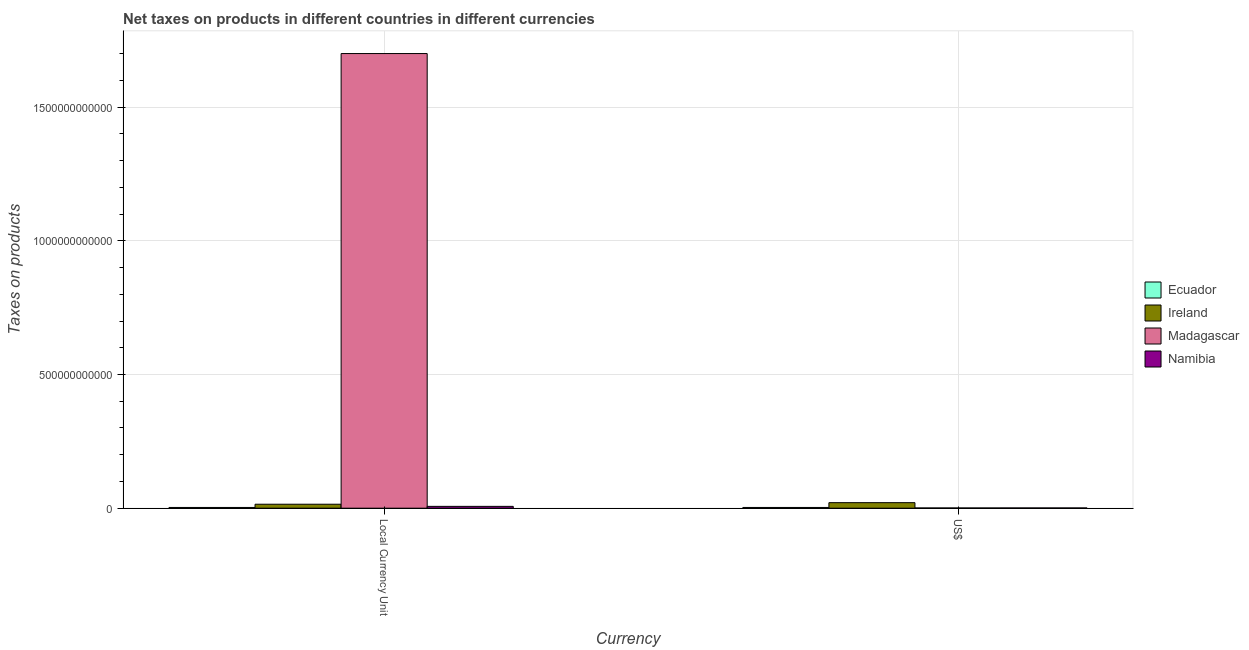How many groups of bars are there?
Your answer should be compact. 2. Are the number of bars per tick equal to the number of legend labels?
Your response must be concise. Yes. Are the number of bars on each tick of the X-axis equal?
Ensure brevity in your answer.  Yes. How many bars are there on the 2nd tick from the left?
Provide a short and direct response. 4. How many bars are there on the 1st tick from the right?
Your answer should be compact. 4. What is the label of the 2nd group of bars from the left?
Keep it short and to the point. US$. What is the net taxes in us$ in Madagascar?
Provide a short and direct response. 8.40e+08. Across all countries, what is the maximum net taxes in constant 2005 us$?
Provide a succinct answer. 1.70e+12. Across all countries, what is the minimum net taxes in constant 2005 us$?
Make the answer very short. 2.74e+09. In which country was the net taxes in constant 2005 us$ maximum?
Your response must be concise. Madagascar. In which country was the net taxes in us$ minimum?
Provide a succinct answer. Madagascar. What is the total net taxes in constant 2005 us$ in the graph?
Keep it short and to the point. 1.73e+12. What is the difference between the net taxes in constant 2005 us$ in Ecuador and that in Madagascar?
Give a very brief answer. -1.70e+12. What is the difference between the net taxes in us$ in Madagascar and the net taxes in constant 2005 us$ in Ecuador?
Offer a terse response. -1.90e+09. What is the average net taxes in constant 2005 us$ per country?
Your answer should be compact. 4.31e+11. What is the difference between the net taxes in constant 2005 us$ and net taxes in us$ in Madagascar?
Your response must be concise. 1.70e+12. In how many countries, is the net taxes in constant 2005 us$ greater than 1500000000000 units?
Offer a terse response. 1. What is the ratio of the net taxes in constant 2005 us$ in Namibia to that in Madagascar?
Offer a terse response. 0. Is the net taxes in constant 2005 us$ in Ireland less than that in Namibia?
Provide a succinct answer. No. What does the 4th bar from the left in Local Currency Unit represents?
Provide a short and direct response. Namibia. What does the 1st bar from the right in US$ represents?
Make the answer very short. Namibia. How many bars are there?
Your answer should be compact. 8. Are all the bars in the graph horizontal?
Provide a succinct answer. No. What is the difference between two consecutive major ticks on the Y-axis?
Offer a terse response. 5.00e+11. Does the graph contain any zero values?
Give a very brief answer. No. What is the title of the graph?
Your answer should be very brief. Net taxes on products in different countries in different currencies. Does "Morocco" appear as one of the legend labels in the graph?
Give a very brief answer. No. What is the label or title of the X-axis?
Ensure brevity in your answer.  Currency. What is the label or title of the Y-axis?
Offer a very short reply. Taxes on products. What is the Taxes on products in Ecuador in Local Currency Unit?
Offer a terse response. 2.74e+09. What is the Taxes on products of Ireland in Local Currency Unit?
Your answer should be compact. 1.49e+1. What is the Taxes on products of Madagascar in Local Currency Unit?
Provide a short and direct response. 1.70e+12. What is the Taxes on products of Namibia in Local Currency Unit?
Give a very brief answer. 6.81e+09. What is the Taxes on products in Ecuador in US$?
Your response must be concise. 2.74e+09. What is the Taxes on products in Ireland in US$?
Your response must be concise. 2.07e+1. What is the Taxes on products of Madagascar in US$?
Make the answer very short. 8.40e+08. What is the Taxes on products in Namibia in US$?
Your response must be concise. 9.37e+08. Across all Currency, what is the maximum Taxes on products of Ecuador?
Make the answer very short. 2.74e+09. Across all Currency, what is the maximum Taxes on products of Ireland?
Ensure brevity in your answer.  2.07e+1. Across all Currency, what is the maximum Taxes on products of Madagascar?
Provide a short and direct response. 1.70e+12. Across all Currency, what is the maximum Taxes on products of Namibia?
Provide a short and direct response. 6.81e+09. Across all Currency, what is the minimum Taxes on products in Ecuador?
Offer a very short reply. 2.74e+09. Across all Currency, what is the minimum Taxes on products in Ireland?
Your answer should be compact. 1.49e+1. Across all Currency, what is the minimum Taxes on products of Madagascar?
Offer a very short reply. 8.40e+08. Across all Currency, what is the minimum Taxes on products of Namibia?
Keep it short and to the point. 9.37e+08. What is the total Taxes on products of Ecuador in the graph?
Make the answer very short. 5.48e+09. What is the total Taxes on products of Ireland in the graph?
Your answer should be compact. 3.55e+1. What is the total Taxes on products of Madagascar in the graph?
Your response must be concise. 1.70e+12. What is the total Taxes on products of Namibia in the graph?
Give a very brief answer. 7.74e+09. What is the difference between the Taxes on products in Ireland in Local Currency Unit and that in US$?
Give a very brief answer. -5.80e+09. What is the difference between the Taxes on products in Madagascar in Local Currency Unit and that in US$?
Ensure brevity in your answer.  1.70e+12. What is the difference between the Taxes on products in Namibia in Local Currency Unit and that in US$?
Give a very brief answer. 5.87e+09. What is the difference between the Taxes on products of Ecuador in Local Currency Unit and the Taxes on products of Ireland in US$?
Your answer should be very brief. -1.79e+1. What is the difference between the Taxes on products in Ecuador in Local Currency Unit and the Taxes on products in Madagascar in US$?
Make the answer very short. 1.90e+09. What is the difference between the Taxes on products in Ecuador in Local Currency Unit and the Taxes on products in Namibia in US$?
Your answer should be compact. 1.80e+09. What is the difference between the Taxes on products of Ireland in Local Currency Unit and the Taxes on products of Madagascar in US$?
Your response must be concise. 1.40e+1. What is the difference between the Taxes on products in Ireland in Local Currency Unit and the Taxes on products in Namibia in US$?
Provide a succinct answer. 1.39e+1. What is the difference between the Taxes on products of Madagascar in Local Currency Unit and the Taxes on products of Namibia in US$?
Give a very brief answer. 1.70e+12. What is the average Taxes on products of Ecuador per Currency?
Your response must be concise. 2.74e+09. What is the average Taxes on products in Ireland per Currency?
Provide a succinct answer. 1.78e+1. What is the average Taxes on products of Madagascar per Currency?
Keep it short and to the point. 8.51e+11. What is the average Taxes on products of Namibia per Currency?
Make the answer very short. 3.87e+09. What is the difference between the Taxes on products of Ecuador and Taxes on products of Ireland in Local Currency Unit?
Provide a short and direct response. -1.21e+1. What is the difference between the Taxes on products of Ecuador and Taxes on products of Madagascar in Local Currency Unit?
Your answer should be compact. -1.70e+12. What is the difference between the Taxes on products of Ecuador and Taxes on products of Namibia in Local Currency Unit?
Keep it short and to the point. -4.06e+09. What is the difference between the Taxes on products of Ireland and Taxes on products of Madagascar in Local Currency Unit?
Your answer should be very brief. -1.69e+12. What is the difference between the Taxes on products of Ireland and Taxes on products of Namibia in Local Currency Unit?
Provide a short and direct response. 8.05e+09. What is the difference between the Taxes on products in Madagascar and Taxes on products in Namibia in Local Currency Unit?
Your answer should be compact. 1.69e+12. What is the difference between the Taxes on products of Ecuador and Taxes on products of Ireland in US$?
Your response must be concise. -1.79e+1. What is the difference between the Taxes on products in Ecuador and Taxes on products in Madagascar in US$?
Provide a short and direct response. 1.90e+09. What is the difference between the Taxes on products of Ecuador and Taxes on products of Namibia in US$?
Your answer should be very brief. 1.80e+09. What is the difference between the Taxes on products in Ireland and Taxes on products in Madagascar in US$?
Offer a very short reply. 1.98e+1. What is the difference between the Taxes on products of Ireland and Taxes on products of Namibia in US$?
Ensure brevity in your answer.  1.97e+1. What is the difference between the Taxes on products in Madagascar and Taxes on products in Namibia in US$?
Offer a terse response. -9.74e+07. What is the ratio of the Taxes on products in Ireland in Local Currency Unit to that in US$?
Make the answer very short. 0.72. What is the ratio of the Taxes on products in Madagascar in Local Currency Unit to that in US$?
Provide a short and direct response. 2025.12. What is the ratio of the Taxes on products in Namibia in Local Currency Unit to that in US$?
Ensure brevity in your answer.  7.26. What is the difference between the highest and the second highest Taxes on products in Ireland?
Offer a terse response. 5.80e+09. What is the difference between the highest and the second highest Taxes on products of Madagascar?
Your answer should be very brief. 1.70e+12. What is the difference between the highest and the second highest Taxes on products in Namibia?
Keep it short and to the point. 5.87e+09. What is the difference between the highest and the lowest Taxes on products in Ecuador?
Make the answer very short. 0. What is the difference between the highest and the lowest Taxes on products of Ireland?
Offer a terse response. 5.80e+09. What is the difference between the highest and the lowest Taxes on products of Madagascar?
Keep it short and to the point. 1.70e+12. What is the difference between the highest and the lowest Taxes on products of Namibia?
Keep it short and to the point. 5.87e+09. 